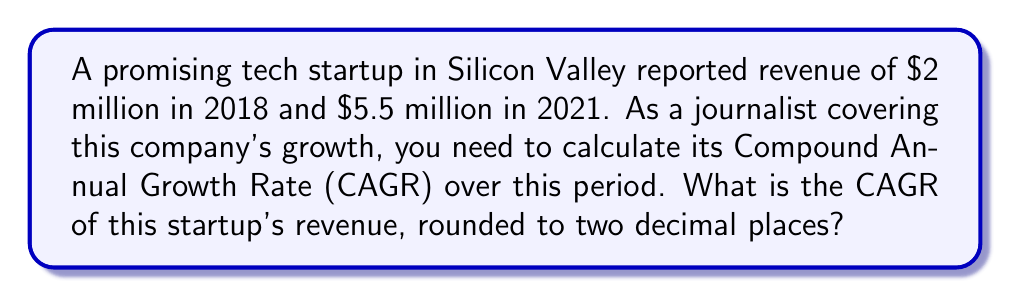Give your solution to this math problem. To calculate the Compound Annual Growth Rate (CAGR), we use the following formula:

$$ CAGR = \left(\frac{Ending Value}{Beginning Value}\right)^{\frac{1}{n}} - 1 $$

Where:
- Ending Value is the final value ($5.5 million)
- Beginning Value is the initial value ($2 million)
- n is the number of years (2021 - 2018 = 3 years)

Let's plug in the values:

$$ CAGR = \left(\frac{5.5}{2}\right)^{\frac{1}{3}} - 1 $$

Now, let's solve step-by-step:

1) First, calculate the fraction inside the parentheses:
   $\frac{5.5}{2} = 2.75$

2) Now, our equation looks like this:
   $$ CAGR = (2.75)^{\frac{1}{3}} - 1 $$

3) Calculate the cube root of 2.75:
   $(2.75)^{\frac{1}{3}} \approx 1.4019$

4) Subtract 1:
   $1.4019 - 1 = 0.4019$

5) Convert to a percentage by multiplying by 100:
   $0.4019 * 100 = 40.19\%$

6) Round to two decimal places:
   $40.19\%$

Therefore, the Compound Annual Growth Rate (CAGR) for this tech startup's revenue from 2018 to 2021 is 40.19%.
Answer: 40.19% 